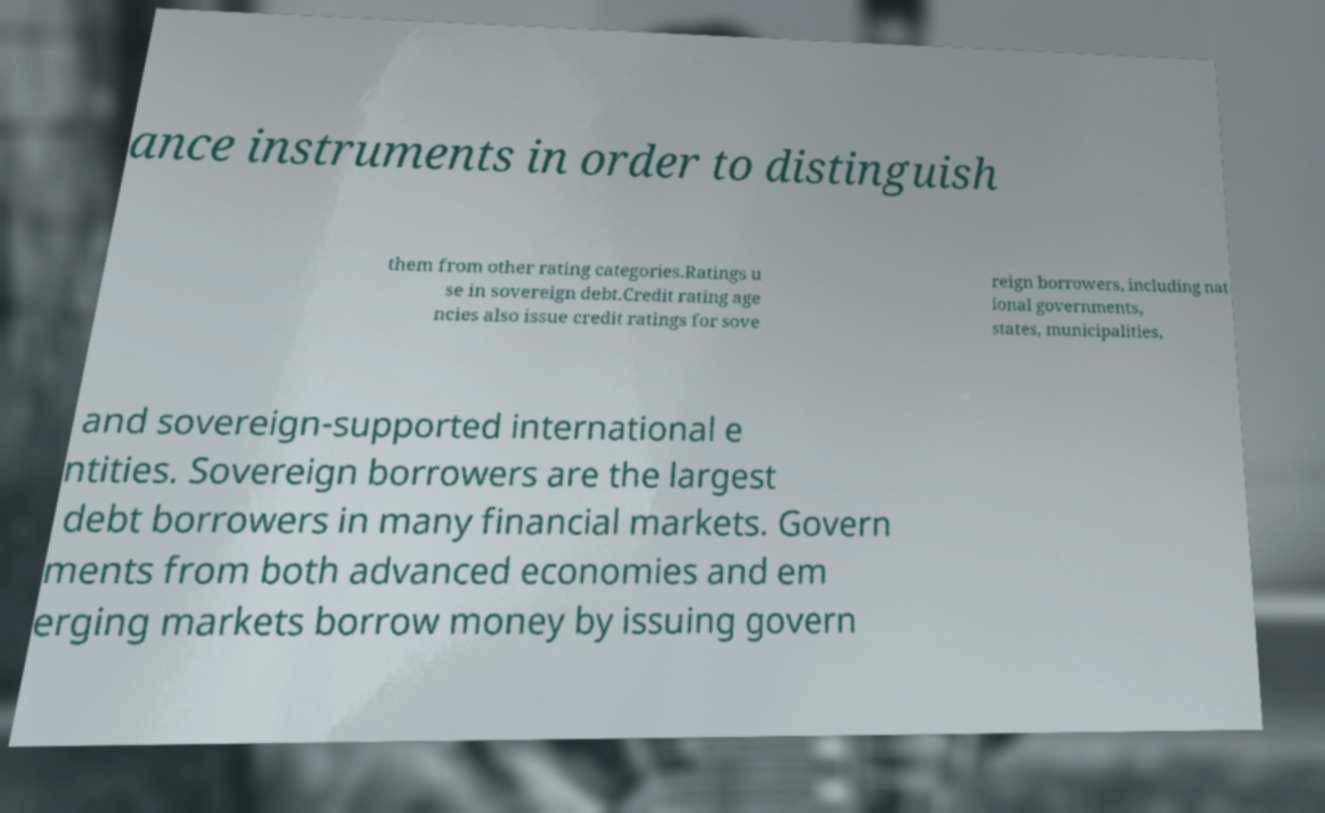What messages or text are displayed in this image? I need them in a readable, typed format. ance instruments in order to distinguish them from other rating categories.Ratings u se in sovereign debt.Credit rating age ncies also issue credit ratings for sove reign borrowers, including nat ional governments, states, municipalities, and sovereign-supported international e ntities. Sovereign borrowers are the largest debt borrowers in many financial markets. Govern ments from both advanced economies and em erging markets borrow money by issuing govern 